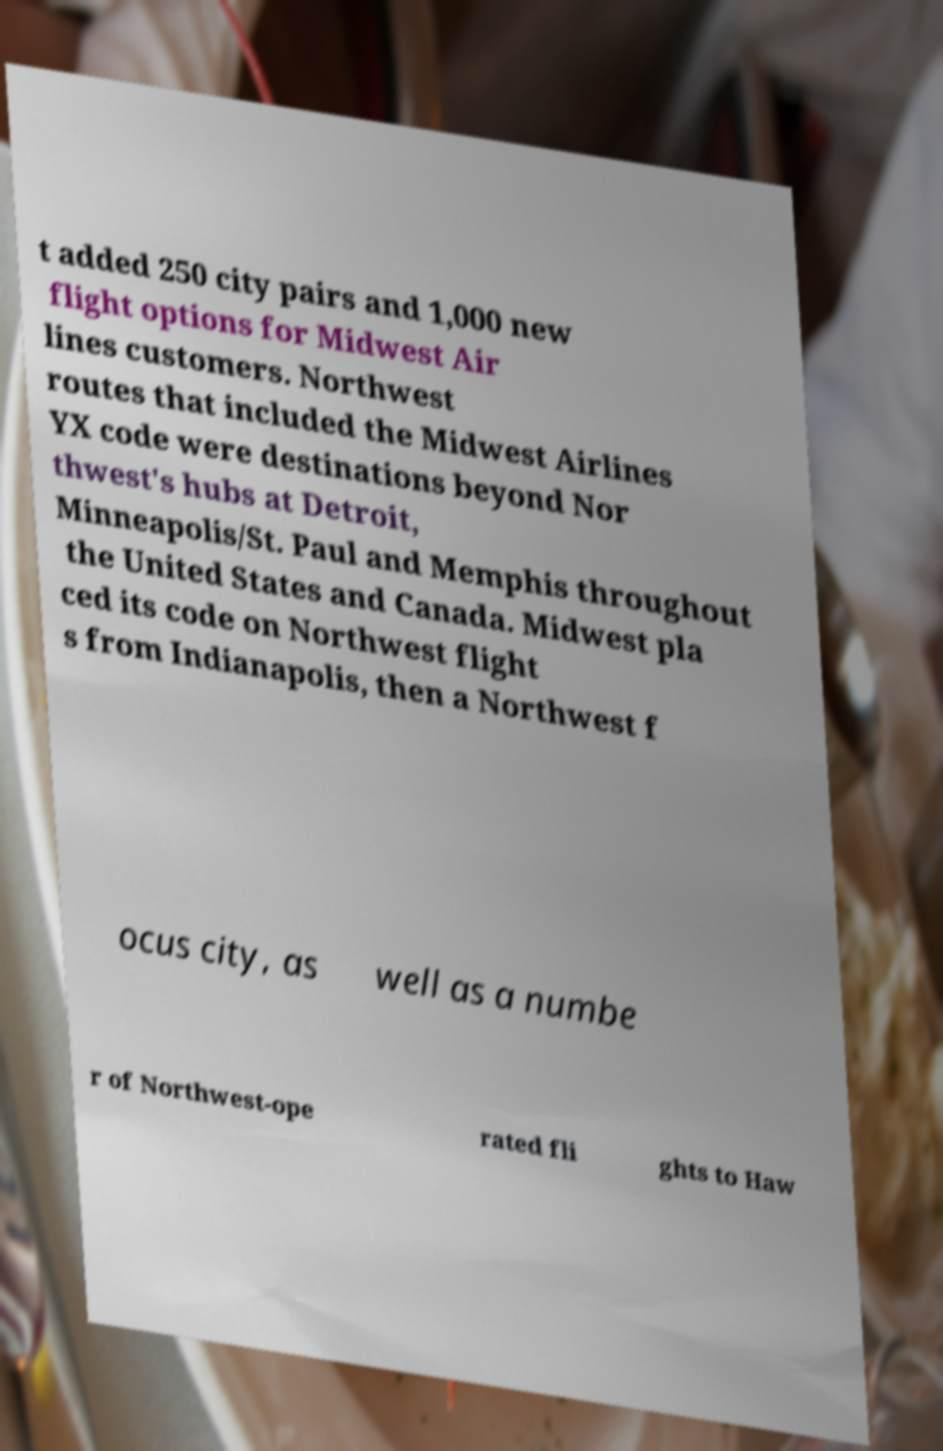Could you assist in decoding the text presented in this image and type it out clearly? t added 250 city pairs and 1,000 new flight options for Midwest Air lines customers. Northwest routes that included the Midwest Airlines YX code were destinations beyond Nor thwest's hubs at Detroit, Minneapolis/St. Paul and Memphis throughout the United States and Canada. Midwest pla ced its code on Northwest flight s from Indianapolis, then a Northwest f ocus city, as well as a numbe r of Northwest-ope rated fli ghts to Haw 